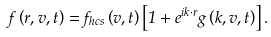Convert formula to latex. <formula><loc_0><loc_0><loc_500><loc_500>f \left ( r , v , t \right ) = f _ { h c s } \left ( v , t \right ) \left [ 1 + e ^ { i k \cdot r } g \left ( k , v , t \right ) \right ] .</formula> 